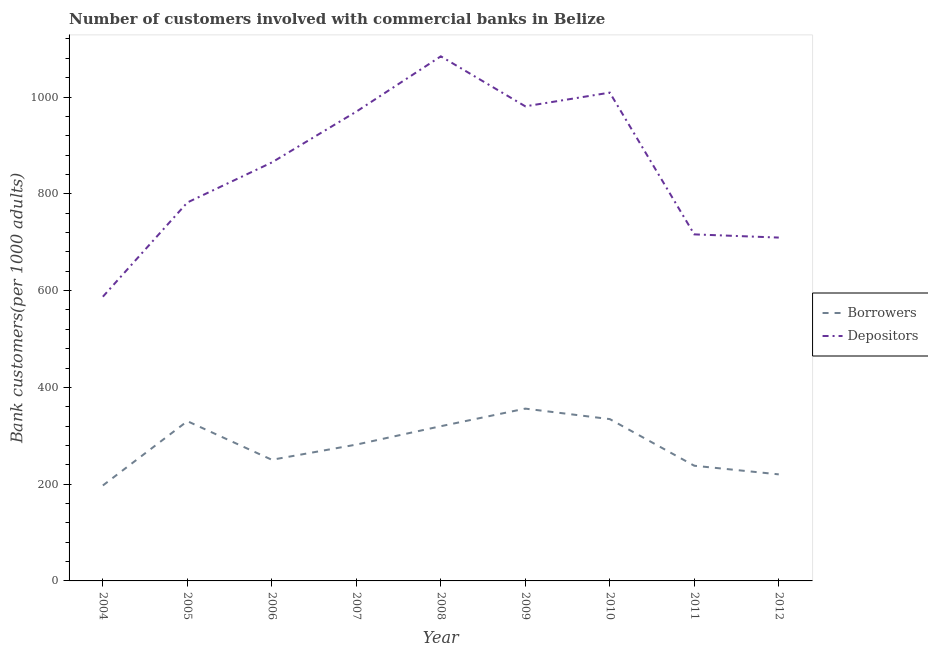Does the line corresponding to number of borrowers intersect with the line corresponding to number of depositors?
Provide a short and direct response. No. What is the number of depositors in 2007?
Offer a very short reply. 969.83. Across all years, what is the maximum number of depositors?
Your response must be concise. 1084.11. Across all years, what is the minimum number of depositors?
Make the answer very short. 587.38. What is the total number of depositors in the graph?
Give a very brief answer. 7703.78. What is the difference between the number of borrowers in 2004 and that in 2006?
Keep it short and to the point. -53.08. What is the difference between the number of borrowers in 2009 and the number of depositors in 2006?
Offer a very short reply. -508.73. What is the average number of borrowers per year?
Offer a terse response. 280.88. In the year 2006, what is the difference between the number of depositors and number of borrowers?
Your answer should be very brief. 614.46. In how many years, is the number of borrowers greater than 80?
Give a very brief answer. 9. What is the ratio of the number of borrowers in 2009 to that in 2010?
Your answer should be very brief. 1.06. Is the difference between the number of depositors in 2006 and 2009 greater than the difference between the number of borrowers in 2006 and 2009?
Keep it short and to the point. No. What is the difference between the highest and the second highest number of depositors?
Make the answer very short. 74.99. What is the difference between the highest and the lowest number of borrowers?
Provide a succinct answer. 158.81. Is the sum of the number of borrowers in 2009 and 2011 greater than the maximum number of depositors across all years?
Keep it short and to the point. No. Is the number of depositors strictly greater than the number of borrowers over the years?
Give a very brief answer. Yes. Where does the legend appear in the graph?
Keep it short and to the point. Center right. How many legend labels are there?
Your response must be concise. 2. What is the title of the graph?
Keep it short and to the point. Number of customers involved with commercial banks in Belize. What is the label or title of the X-axis?
Ensure brevity in your answer.  Year. What is the label or title of the Y-axis?
Offer a terse response. Bank customers(per 1000 adults). What is the Bank customers(per 1000 adults) in Borrowers in 2004?
Ensure brevity in your answer.  197.26. What is the Bank customers(per 1000 adults) of Depositors in 2004?
Provide a short and direct response. 587.38. What is the Bank customers(per 1000 adults) in Borrowers in 2005?
Your response must be concise. 330.14. What is the Bank customers(per 1000 adults) in Depositors in 2005?
Your answer should be very brief. 782.08. What is the Bank customers(per 1000 adults) in Borrowers in 2006?
Offer a terse response. 250.34. What is the Bank customers(per 1000 adults) in Depositors in 2006?
Give a very brief answer. 864.8. What is the Bank customers(per 1000 adults) in Borrowers in 2007?
Give a very brief answer. 281.72. What is the Bank customers(per 1000 adults) of Depositors in 2007?
Make the answer very short. 969.83. What is the Bank customers(per 1000 adults) of Borrowers in 2008?
Your response must be concise. 319.74. What is the Bank customers(per 1000 adults) of Depositors in 2008?
Provide a succinct answer. 1084.11. What is the Bank customers(per 1000 adults) in Borrowers in 2009?
Provide a short and direct response. 356.07. What is the Bank customers(per 1000 adults) of Depositors in 2009?
Your answer should be compact. 980.77. What is the Bank customers(per 1000 adults) in Borrowers in 2010?
Provide a succinct answer. 334.41. What is the Bank customers(per 1000 adults) in Depositors in 2010?
Give a very brief answer. 1009.11. What is the Bank customers(per 1000 adults) in Borrowers in 2011?
Your answer should be very brief. 238.05. What is the Bank customers(per 1000 adults) of Depositors in 2011?
Offer a very short reply. 716.16. What is the Bank customers(per 1000 adults) of Borrowers in 2012?
Your response must be concise. 220.2. What is the Bank customers(per 1000 adults) of Depositors in 2012?
Make the answer very short. 709.54. Across all years, what is the maximum Bank customers(per 1000 adults) in Borrowers?
Give a very brief answer. 356.07. Across all years, what is the maximum Bank customers(per 1000 adults) of Depositors?
Your answer should be very brief. 1084.11. Across all years, what is the minimum Bank customers(per 1000 adults) in Borrowers?
Provide a succinct answer. 197.26. Across all years, what is the minimum Bank customers(per 1000 adults) of Depositors?
Keep it short and to the point. 587.38. What is the total Bank customers(per 1000 adults) of Borrowers in the graph?
Ensure brevity in your answer.  2527.93. What is the total Bank customers(per 1000 adults) of Depositors in the graph?
Your answer should be very brief. 7703.78. What is the difference between the Bank customers(per 1000 adults) of Borrowers in 2004 and that in 2005?
Make the answer very short. -132.88. What is the difference between the Bank customers(per 1000 adults) in Depositors in 2004 and that in 2005?
Give a very brief answer. -194.7. What is the difference between the Bank customers(per 1000 adults) of Borrowers in 2004 and that in 2006?
Give a very brief answer. -53.08. What is the difference between the Bank customers(per 1000 adults) in Depositors in 2004 and that in 2006?
Your answer should be compact. -277.42. What is the difference between the Bank customers(per 1000 adults) of Borrowers in 2004 and that in 2007?
Your answer should be compact. -84.46. What is the difference between the Bank customers(per 1000 adults) in Depositors in 2004 and that in 2007?
Offer a very short reply. -382.45. What is the difference between the Bank customers(per 1000 adults) in Borrowers in 2004 and that in 2008?
Provide a succinct answer. -122.48. What is the difference between the Bank customers(per 1000 adults) of Depositors in 2004 and that in 2008?
Your response must be concise. -496.73. What is the difference between the Bank customers(per 1000 adults) of Borrowers in 2004 and that in 2009?
Provide a succinct answer. -158.81. What is the difference between the Bank customers(per 1000 adults) in Depositors in 2004 and that in 2009?
Offer a very short reply. -393.39. What is the difference between the Bank customers(per 1000 adults) in Borrowers in 2004 and that in 2010?
Provide a succinct answer. -137.15. What is the difference between the Bank customers(per 1000 adults) of Depositors in 2004 and that in 2010?
Your answer should be compact. -421.73. What is the difference between the Bank customers(per 1000 adults) in Borrowers in 2004 and that in 2011?
Your answer should be very brief. -40.79. What is the difference between the Bank customers(per 1000 adults) in Depositors in 2004 and that in 2011?
Make the answer very short. -128.78. What is the difference between the Bank customers(per 1000 adults) in Borrowers in 2004 and that in 2012?
Keep it short and to the point. -22.95. What is the difference between the Bank customers(per 1000 adults) of Depositors in 2004 and that in 2012?
Make the answer very short. -122.16. What is the difference between the Bank customers(per 1000 adults) of Borrowers in 2005 and that in 2006?
Keep it short and to the point. 79.8. What is the difference between the Bank customers(per 1000 adults) in Depositors in 2005 and that in 2006?
Offer a terse response. -82.72. What is the difference between the Bank customers(per 1000 adults) in Borrowers in 2005 and that in 2007?
Your answer should be compact. 48.42. What is the difference between the Bank customers(per 1000 adults) of Depositors in 2005 and that in 2007?
Your response must be concise. -187.75. What is the difference between the Bank customers(per 1000 adults) of Borrowers in 2005 and that in 2008?
Your answer should be compact. 10.4. What is the difference between the Bank customers(per 1000 adults) in Depositors in 2005 and that in 2008?
Offer a terse response. -302.03. What is the difference between the Bank customers(per 1000 adults) in Borrowers in 2005 and that in 2009?
Make the answer very short. -25.93. What is the difference between the Bank customers(per 1000 adults) of Depositors in 2005 and that in 2009?
Ensure brevity in your answer.  -198.69. What is the difference between the Bank customers(per 1000 adults) in Borrowers in 2005 and that in 2010?
Keep it short and to the point. -4.27. What is the difference between the Bank customers(per 1000 adults) in Depositors in 2005 and that in 2010?
Offer a very short reply. -227.03. What is the difference between the Bank customers(per 1000 adults) in Borrowers in 2005 and that in 2011?
Give a very brief answer. 92.1. What is the difference between the Bank customers(per 1000 adults) of Depositors in 2005 and that in 2011?
Give a very brief answer. 65.92. What is the difference between the Bank customers(per 1000 adults) of Borrowers in 2005 and that in 2012?
Your answer should be very brief. 109.94. What is the difference between the Bank customers(per 1000 adults) of Depositors in 2005 and that in 2012?
Your response must be concise. 72.54. What is the difference between the Bank customers(per 1000 adults) in Borrowers in 2006 and that in 2007?
Offer a very short reply. -31.38. What is the difference between the Bank customers(per 1000 adults) in Depositors in 2006 and that in 2007?
Offer a very short reply. -105.03. What is the difference between the Bank customers(per 1000 adults) in Borrowers in 2006 and that in 2008?
Your answer should be compact. -69.4. What is the difference between the Bank customers(per 1000 adults) of Depositors in 2006 and that in 2008?
Give a very brief answer. -219.3. What is the difference between the Bank customers(per 1000 adults) in Borrowers in 2006 and that in 2009?
Your answer should be very brief. -105.73. What is the difference between the Bank customers(per 1000 adults) of Depositors in 2006 and that in 2009?
Provide a short and direct response. -115.97. What is the difference between the Bank customers(per 1000 adults) of Borrowers in 2006 and that in 2010?
Your answer should be compact. -84.07. What is the difference between the Bank customers(per 1000 adults) of Depositors in 2006 and that in 2010?
Ensure brevity in your answer.  -144.31. What is the difference between the Bank customers(per 1000 adults) in Borrowers in 2006 and that in 2011?
Your response must be concise. 12.29. What is the difference between the Bank customers(per 1000 adults) in Depositors in 2006 and that in 2011?
Your response must be concise. 148.64. What is the difference between the Bank customers(per 1000 adults) in Borrowers in 2006 and that in 2012?
Your answer should be compact. 30.13. What is the difference between the Bank customers(per 1000 adults) of Depositors in 2006 and that in 2012?
Ensure brevity in your answer.  155.26. What is the difference between the Bank customers(per 1000 adults) in Borrowers in 2007 and that in 2008?
Offer a very short reply. -38.02. What is the difference between the Bank customers(per 1000 adults) of Depositors in 2007 and that in 2008?
Keep it short and to the point. -114.27. What is the difference between the Bank customers(per 1000 adults) of Borrowers in 2007 and that in 2009?
Ensure brevity in your answer.  -74.35. What is the difference between the Bank customers(per 1000 adults) in Depositors in 2007 and that in 2009?
Ensure brevity in your answer.  -10.94. What is the difference between the Bank customers(per 1000 adults) of Borrowers in 2007 and that in 2010?
Provide a short and direct response. -52.68. What is the difference between the Bank customers(per 1000 adults) in Depositors in 2007 and that in 2010?
Ensure brevity in your answer.  -39.28. What is the difference between the Bank customers(per 1000 adults) of Borrowers in 2007 and that in 2011?
Your answer should be compact. 43.68. What is the difference between the Bank customers(per 1000 adults) of Depositors in 2007 and that in 2011?
Provide a succinct answer. 253.67. What is the difference between the Bank customers(per 1000 adults) in Borrowers in 2007 and that in 2012?
Give a very brief answer. 61.52. What is the difference between the Bank customers(per 1000 adults) in Depositors in 2007 and that in 2012?
Offer a very short reply. 260.29. What is the difference between the Bank customers(per 1000 adults) of Borrowers in 2008 and that in 2009?
Give a very brief answer. -36.33. What is the difference between the Bank customers(per 1000 adults) in Depositors in 2008 and that in 2009?
Provide a short and direct response. 103.33. What is the difference between the Bank customers(per 1000 adults) of Borrowers in 2008 and that in 2010?
Ensure brevity in your answer.  -14.67. What is the difference between the Bank customers(per 1000 adults) in Depositors in 2008 and that in 2010?
Keep it short and to the point. 74.99. What is the difference between the Bank customers(per 1000 adults) in Borrowers in 2008 and that in 2011?
Give a very brief answer. 81.69. What is the difference between the Bank customers(per 1000 adults) of Depositors in 2008 and that in 2011?
Offer a terse response. 367.95. What is the difference between the Bank customers(per 1000 adults) in Borrowers in 2008 and that in 2012?
Ensure brevity in your answer.  99.53. What is the difference between the Bank customers(per 1000 adults) of Depositors in 2008 and that in 2012?
Make the answer very short. 374.57. What is the difference between the Bank customers(per 1000 adults) in Borrowers in 2009 and that in 2010?
Keep it short and to the point. 21.67. What is the difference between the Bank customers(per 1000 adults) of Depositors in 2009 and that in 2010?
Your answer should be very brief. -28.34. What is the difference between the Bank customers(per 1000 adults) in Borrowers in 2009 and that in 2011?
Offer a very short reply. 118.03. What is the difference between the Bank customers(per 1000 adults) in Depositors in 2009 and that in 2011?
Provide a short and direct response. 264.62. What is the difference between the Bank customers(per 1000 adults) in Borrowers in 2009 and that in 2012?
Your answer should be compact. 135.87. What is the difference between the Bank customers(per 1000 adults) in Depositors in 2009 and that in 2012?
Your answer should be very brief. 271.24. What is the difference between the Bank customers(per 1000 adults) of Borrowers in 2010 and that in 2011?
Give a very brief answer. 96.36. What is the difference between the Bank customers(per 1000 adults) in Depositors in 2010 and that in 2011?
Offer a terse response. 292.95. What is the difference between the Bank customers(per 1000 adults) in Borrowers in 2010 and that in 2012?
Give a very brief answer. 114.2. What is the difference between the Bank customers(per 1000 adults) of Depositors in 2010 and that in 2012?
Provide a succinct answer. 299.57. What is the difference between the Bank customers(per 1000 adults) in Borrowers in 2011 and that in 2012?
Offer a very short reply. 17.84. What is the difference between the Bank customers(per 1000 adults) in Depositors in 2011 and that in 2012?
Your answer should be compact. 6.62. What is the difference between the Bank customers(per 1000 adults) of Borrowers in 2004 and the Bank customers(per 1000 adults) of Depositors in 2005?
Offer a terse response. -584.82. What is the difference between the Bank customers(per 1000 adults) in Borrowers in 2004 and the Bank customers(per 1000 adults) in Depositors in 2006?
Provide a short and direct response. -667.54. What is the difference between the Bank customers(per 1000 adults) in Borrowers in 2004 and the Bank customers(per 1000 adults) in Depositors in 2007?
Ensure brevity in your answer.  -772.57. What is the difference between the Bank customers(per 1000 adults) of Borrowers in 2004 and the Bank customers(per 1000 adults) of Depositors in 2008?
Offer a terse response. -886.85. What is the difference between the Bank customers(per 1000 adults) of Borrowers in 2004 and the Bank customers(per 1000 adults) of Depositors in 2009?
Ensure brevity in your answer.  -783.51. What is the difference between the Bank customers(per 1000 adults) in Borrowers in 2004 and the Bank customers(per 1000 adults) in Depositors in 2010?
Keep it short and to the point. -811.85. What is the difference between the Bank customers(per 1000 adults) in Borrowers in 2004 and the Bank customers(per 1000 adults) in Depositors in 2011?
Ensure brevity in your answer.  -518.9. What is the difference between the Bank customers(per 1000 adults) in Borrowers in 2004 and the Bank customers(per 1000 adults) in Depositors in 2012?
Provide a succinct answer. -512.28. What is the difference between the Bank customers(per 1000 adults) in Borrowers in 2005 and the Bank customers(per 1000 adults) in Depositors in 2006?
Your answer should be compact. -534.66. What is the difference between the Bank customers(per 1000 adults) of Borrowers in 2005 and the Bank customers(per 1000 adults) of Depositors in 2007?
Keep it short and to the point. -639.69. What is the difference between the Bank customers(per 1000 adults) of Borrowers in 2005 and the Bank customers(per 1000 adults) of Depositors in 2008?
Offer a terse response. -753.96. What is the difference between the Bank customers(per 1000 adults) of Borrowers in 2005 and the Bank customers(per 1000 adults) of Depositors in 2009?
Offer a very short reply. -650.63. What is the difference between the Bank customers(per 1000 adults) in Borrowers in 2005 and the Bank customers(per 1000 adults) in Depositors in 2010?
Your response must be concise. -678.97. What is the difference between the Bank customers(per 1000 adults) in Borrowers in 2005 and the Bank customers(per 1000 adults) in Depositors in 2011?
Make the answer very short. -386.02. What is the difference between the Bank customers(per 1000 adults) of Borrowers in 2005 and the Bank customers(per 1000 adults) of Depositors in 2012?
Your answer should be very brief. -379.4. What is the difference between the Bank customers(per 1000 adults) of Borrowers in 2006 and the Bank customers(per 1000 adults) of Depositors in 2007?
Provide a succinct answer. -719.49. What is the difference between the Bank customers(per 1000 adults) in Borrowers in 2006 and the Bank customers(per 1000 adults) in Depositors in 2008?
Your answer should be very brief. -833.77. What is the difference between the Bank customers(per 1000 adults) of Borrowers in 2006 and the Bank customers(per 1000 adults) of Depositors in 2009?
Provide a succinct answer. -730.43. What is the difference between the Bank customers(per 1000 adults) in Borrowers in 2006 and the Bank customers(per 1000 adults) in Depositors in 2010?
Provide a short and direct response. -758.77. What is the difference between the Bank customers(per 1000 adults) in Borrowers in 2006 and the Bank customers(per 1000 adults) in Depositors in 2011?
Your answer should be compact. -465.82. What is the difference between the Bank customers(per 1000 adults) in Borrowers in 2006 and the Bank customers(per 1000 adults) in Depositors in 2012?
Provide a short and direct response. -459.2. What is the difference between the Bank customers(per 1000 adults) in Borrowers in 2007 and the Bank customers(per 1000 adults) in Depositors in 2008?
Provide a succinct answer. -802.38. What is the difference between the Bank customers(per 1000 adults) in Borrowers in 2007 and the Bank customers(per 1000 adults) in Depositors in 2009?
Provide a succinct answer. -699.05. What is the difference between the Bank customers(per 1000 adults) in Borrowers in 2007 and the Bank customers(per 1000 adults) in Depositors in 2010?
Your answer should be compact. -727.39. What is the difference between the Bank customers(per 1000 adults) in Borrowers in 2007 and the Bank customers(per 1000 adults) in Depositors in 2011?
Your answer should be very brief. -434.44. What is the difference between the Bank customers(per 1000 adults) in Borrowers in 2007 and the Bank customers(per 1000 adults) in Depositors in 2012?
Your answer should be very brief. -427.81. What is the difference between the Bank customers(per 1000 adults) of Borrowers in 2008 and the Bank customers(per 1000 adults) of Depositors in 2009?
Your response must be concise. -661.03. What is the difference between the Bank customers(per 1000 adults) in Borrowers in 2008 and the Bank customers(per 1000 adults) in Depositors in 2010?
Make the answer very short. -689.37. What is the difference between the Bank customers(per 1000 adults) in Borrowers in 2008 and the Bank customers(per 1000 adults) in Depositors in 2011?
Provide a succinct answer. -396.42. What is the difference between the Bank customers(per 1000 adults) of Borrowers in 2008 and the Bank customers(per 1000 adults) of Depositors in 2012?
Provide a succinct answer. -389.8. What is the difference between the Bank customers(per 1000 adults) of Borrowers in 2009 and the Bank customers(per 1000 adults) of Depositors in 2010?
Provide a short and direct response. -653.04. What is the difference between the Bank customers(per 1000 adults) in Borrowers in 2009 and the Bank customers(per 1000 adults) in Depositors in 2011?
Make the answer very short. -360.09. What is the difference between the Bank customers(per 1000 adults) of Borrowers in 2009 and the Bank customers(per 1000 adults) of Depositors in 2012?
Make the answer very short. -353.46. What is the difference between the Bank customers(per 1000 adults) of Borrowers in 2010 and the Bank customers(per 1000 adults) of Depositors in 2011?
Make the answer very short. -381.75. What is the difference between the Bank customers(per 1000 adults) in Borrowers in 2010 and the Bank customers(per 1000 adults) in Depositors in 2012?
Provide a short and direct response. -375.13. What is the difference between the Bank customers(per 1000 adults) of Borrowers in 2011 and the Bank customers(per 1000 adults) of Depositors in 2012?
Your answer should be very brief. -471.49. What is the average Bank customers(per 1000 adults) in Borrowers per year?
Make the answer very short. 280.88. What is the average Bank customers(per 1000 adults) of Depositors per year?
Make the answer very short. 855.98. In the year 2004, what is the difference between the Bank customers(per 1000 adults) of Borrowers and Bank customers(per 1000 adults) of Depositors?
Provide a short and direct response. -390.12. In the year 2005, what is the difference between the Bank customers(per 1000 adults) of Borrowers and Bank customers(per 1000 adults) of Depositors?
Keep it short and to the point. -451.94. In the year 2006, what is the difference between the Bank customers(per 1000 adults) in Borrowers and Bank customers(per 1000 adults) in Depositors?
Offer a very short reply. -614.46. In the year 2007, what is the difference between the Bank customers(per 1000 adults) of Borrowers and Bank customers(per 1000 adults) of Depositors?
Your answer should be very brief. -688.11. In the year 2008, what is the difference between the Bank customers(per 1000 adults) in Borrowers and Bank customers(per 1000 adults) in Depositors?
Make the answer very short. -764.37. In the year 2009, what is the difference between the Bank customers(per 1000 adults) in Borrowers and Bank customers(per 1000 adults) in Depositors?
Ensure brevity in your answer.  -624.7. In the year 2010, what is the difference between the Bank customers(per 1000 adults) of Borrowers and Bank customers(per 1000 adults) of Depositors?
Give a very brief answer. -674.71. In the year 2011, what is the difference between the Bank customers(per 1000 adults) in Borrowers and Bank customers(per 1000 adults) in Depositors?
Ensure brevity in your answer.  -478.11. In the year 2012, what is the difference between the Bank customers(per 1000 adults) in Borrowers and Bank customers(per 1000 adults) in Depositors?
Offer a very short reply. -489.33. What is the ratio of the Bank customers(per 1000 adults) in Borrowers in 2004 to that in 2005?
Provide a short and direct response. 0.6. What is the ratio of the Bank customers(per 1000 adults) in Depositors in 2004 to that in 2005?
Offer a terse response. 0.75. What is the ratio of the Bank customers(per 1000 adults) of Borrowers in 2004 to that in 2006?
Your response must be concise. 0.79. What is the ratio of the Bank customers(per 1000 adults) in Depositors in 2004 to that in 2006?
Provide a succinct answer. 0.68. What is the ratio of the Bank customers(per 1000 adults) in Borrowers in 2004 to that in 2007?
Your answer should be compact. 0.7. What is the ratio of the Bank customers(per 1000 adults) in Depositors in 2004 to that in 2007?
Ensure brevity in your answer.  0.61. What is the ratio of the Bank customers(per 1000 adults) in Borrowers in 2004 to that in 2008?
Your answer should be very brief. 0.62. What is the ratio of the Bank customers(per 1000 adults) in Depositors in 2004 to that in 2008?
Keep it short and to the point. 0.54. What is the ratio of the Bank customers(per 1000 adults) in Borrowers in 2004 to that in 2009?
Give a very brief answer. 0.55. What is the ratio of the Bank customers(per 1000 adults) of Depositors in 2004 to that in 2009?
Provide a short and direct response. 0.6. What is the ratio of the Bank customers(per 1000 adults) in Borrowers in 2004 to that in 2010?
Provide a short and direct response. 0.59. What is the ratio of the Bank customers(per 1000 adults) in Depositors in 2004 to that in 2010?
Give a very brief answer. 0.58. What is the ratio of the Bank customers(per 1000 adults) in Borrowers in 2004 to that in 2011?
Offer a terse response. 0.83. What is the ratio of the Bank customers(per 1000 adults) in Depositors in 2004 to that in 2011?
Offer a terse response. 0.82. What is the ratio of the Bank customers(per 1000 adults) of Borrowers in 2004 to that in 2012?
Offer a very short reply. 0.9. What is the ratio of the Bank customers(per 1000 adults) in Depositors in 2004 to that in 2012?
Keep it short and to the point. 0.83. What is the ratio of the Bank customers(per 1000 adults) of Borrowers in 2005 to that in 2006?
Keep it short and to the point. 1.32. What is the ratio of the Bank customers(per 1000 adults) in Depositors in 2005 to that in 2006?
Offer a very short reply. 0.9. What is the ratio of the Bank customers(per 1000 adults) of Borrowers in 2005 to that in 2007?
Provide a short and direct response. 1.17. What is the ratio of the Bank customers(per 1000 adults) in Depositors in 2005 to that in 2007?
Offer a very short reply. 0.81. What is the ratio of the Bank customers(per 1000 adults) of Borrowers in 2005 to that in 2008?
Provide a short and direct response. 1.03. What is the ratio of the Bank customers(per 1000 adults) in Depositors in 2005 to that in 2008?
Provide a short and direct response. 0.72. What is the ratio of the Bank customers(per 1000 adults) in Borrowers in 2005 to that in 2009?
Your response must be concise. 0.93. What is the ratio of the Bank customers(per 1000 adults) in Depositors in 2005 to that in 2009?
Offer a very short reply. 0.8. What is the ratio of the Bank customers(per 1000 adults) of Borrowers in 2005 to that in 2010?
Keep it short and to the point. 0.99. What is the ratio of the Bank customers(per 1000 adults) of Depositors in 2005 to that in 2010?
Provide a short and direct response. 0.78. What is the ratio of the Bank customers(per 1000 adults) in Borrowers in 2005 to that in 2011?
Provide a succinct answer. 1.39. What is the ratio of the Bank customers(per 1000 adults) of Depositors in 2005 to that in 2011?
Provide a succinct answer. 1.09. What is the ratio of the Bank customers(per 1000 adults) of Borrowers in 2005 to that in 2012?
Give a very brief answer. 1.5. What is the ratio of the Bank customers(per 1000 adults) in Depositors in 2005 to that in 2012?
Provide a succinct answer. 1.1. What is the ratio of the Bank customers(per 1000 adults) of Borrowers in 2006 to that in 2007?
Make the answer very short. 0.89. What is the ratio of the Bank customers(per 1000 adults) of Depositors in 2006 to that in 2007?
Offer a very short reply. 0.89. What is the ratio of the Bank customers(per 1000 adults) in Borrowers in 2006 to that in 2008?
Provide a succinct answer. 0.78. What is the ratio of the Bank customers(per 1000 adults) in Depositors in 2006 to that in 2008?
Provide a succinct answer. 0.8. What is the ratio of the Bank customers(per 1000 adults) in Borrowers in 2006 to that in 2009?
Give a very brief answer. 0.7. What is the ratio of the Bank customers(per 1000 adults) in Depositors in 2006 to that in 2009?
Give a very brief answer. 0.88. What is the ratio of the Bank customers(per 1000 adults) in Borrowers in 2006 to that in 2010?
Your answer should be very brief. 0.75. What is the ratio of the Bank customers(per 1000 adults) of Depositors in 2006 to that in 2010?
Provide a succinct answer. 0.86. What is the ratio of the Bank customers(per 1000 adults) of Borrowers in 2006 to that in 2011?
Ensure brevity in your answer.  1.05. What is the ratio of the Bank customers(per 1000 adults) in Depositors in 2006 to that in 2011?
Ensure brevity in your answer.  1.21. What is the ratio of the Bank customers(per 1000 adults) in Borrowers in 2006 to that in 2012?
Make the answer very short. 1.14. What is the ratio of the Bank customers(per 1000 adults) of Depositors in 2006 to that in 2012?
Your answer should be compact. 1.22. What is the ratio of the Bank customers(per 1000 adults) in Borrowers in 2007 to that in 2008?
Ensure brevity in your answer.  0.88. What is the ratio of the Bank customers(per 1000 adults) of Depositors in 2007 to that in 2008?
Your answer should be very brief. 0.89. What is the ratio of the Bank customers(per 1000 adults) in Borrowers in 2007 to that in 2009?
Your answer should be compact. 0.79. What is the ratio of the Bank customers(per 1000 adults) of Borrowers in 2007 to that in 2010?
Provide a succinct answer. 0.84. What is the ratio of the Bank customers(per 1000 adults) of Depositors in 2007 to that in 2010?
Give a very brief answer. 0.96. What is the ratio of the Bank customers(per 1000 adults) of Borrowers in 2007 to that in 2011?
Your answer should be compact. 1.18. What is the ratio of the Bank customers(per 1000 adults) of Depositors in 2007 to that in 2011?
Your response must be concise. 1.35. What is the ratio of the Bank customers(per 1000 adults) of Borrowers in 2007 to that in 2012?
Keep it short and to the point. 1.28. What is the ratio of the Bank customers(per 1000 adults) of Depositors in 2007 to that in 2012?
Give a very brief answer. 1.37. What is the ratio of the Bank customers(per 1000 adults) in Borrowers in 2008 to that in 2009?
Your answer should be very brief. 0.9. What is the ratio of the Bank customers(per 1000 adults) of Depositors in 2008 to that in 2009?
Give a very brief answer. 1.11. What is the ratio of the Bank customers(per 1000 adults) in Borrowers in 2008 to that in 2010?
Offer a very short reply. 0.96. What is the ratio of the Bank customers(per 1000 adults) of Depositors in 2008 to that in 2010?
Keep it short and to the point. 1.07. What is the ratio of the Bank customers(per 1000 adults) in Borrowers in 2008 to that in 2011?
Give a very brief answer. 1.34. What is the ratio of the Bank customers(per 1000 adults) in Depositors in 2008 to that in 2011?
Provide a short and direct response. 1.51. What is the ratio of the Bank customers(per 1000 adults) in Borrowers in 2008 to that in 2012?
Ensure brevity in your answer.  1.45. What is the ratio of the Bank customers(per 1000 adults) of Depositors in 2008 to that in 2012?
Your answer should be very brief. 1.53. What is the ratio of the Bank customers(per 1000 adults) in Borrowers in 2009 to that in 2010?
Your response must be concise. 1.06. What is the ratio of the Bank customers(per 1000 adults) of Depositors in 2009 to that in 2010?
Your answer should be very brief. 0.97. What is the ratio of the Bank customers(per 1000 adults) of Borrowers in 2009 to that in 2011?
Provide a succinct answer. 1.5. What is the ratio of the Bank customers(per 1000 adults) of Depositors in 2009 to that in 2011?
Your answer should be very brief. 1.37. What is the ratio of the Bank customers(per 1000 adults) in Borrowers in 2009 to that in 2012?
Your answer should be compact. 1.62. What is the ratio of the Bank customers(per 1000 adults) in Depositors in 2009 to that in 2012?
Your answer should be compact. 1.38. What is the ratio of the Bank customers(per 1000 adults) in Borrowers in 2010 to that in 2011?
Ensure brevity in your answer.  1.4. What is the ratio of the Bank customers(per 1000 adults) in Depositors in 2010 to that in 2011?
Make the answer very short. 1.41. What is the ratio of the Bank customers(per 1000 adults) of Borrowers in 2010 to that in 2012?
Your response must be concise. 1.52. What is the ratio of the Bank customers(per 1000 adults) in Depositors in 2010 to that in 2012?
Your response must be concise. 1.42. What is the ratio of the Bank customers(per 1000 adults) of Borrowers in 2011 to that in 2012?
Offer a terse response. 1.08. What is the ratio of the Bank customers(per 1000 adults) in Depositors in 2011 to that in 2012?
Keep it short and to the point. 1.01. What is the difference between the highest and the second highest Bank customers(per 1000 adults) in Borrowers?
Your answer should be very brief. 21.67. What is the difference between the highest and the second highest Bank customers(per 1000 adults) of Depositors?
Keep it short and to the point. 74.99. What is the difference between the highest and the lowest Bank customers(per 1000 adults) of Borrowers?
Ensure brevity in your answer.  158.81. What is the difference between the highest and the lowest Bank customers(per 1000 adults) in Depositors?
Ensure brevity in your answer.  496.73. 